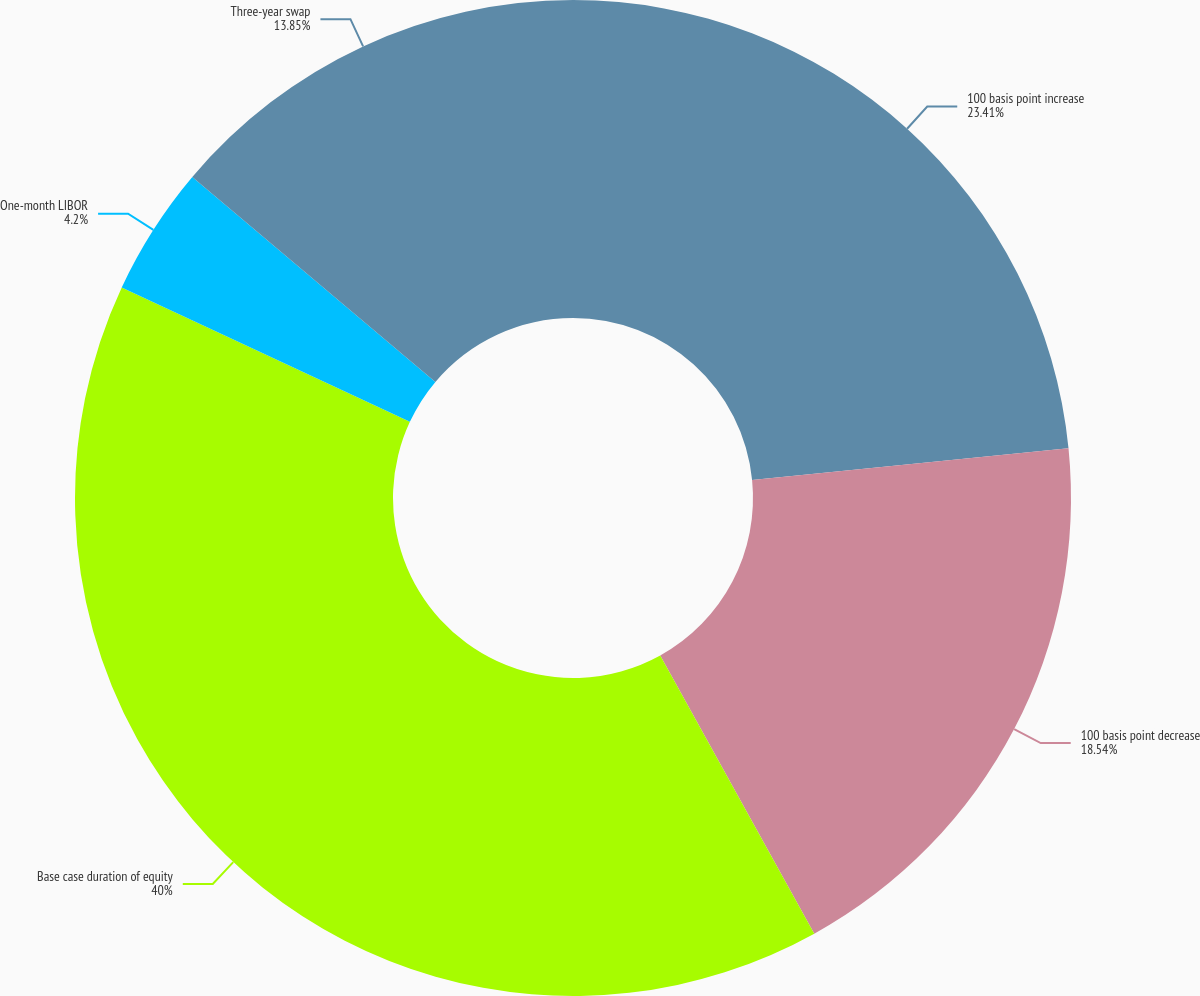Convert chart. <chart><loc_0><loc_0><loc_500><loc_500><pie_chart><fcel>100 basis point increase<fcel>100 basis point decrease<fcel>Base case duration of equity<fcel>One-month LIBOR<fcel>Three-year swap<nl><fcel>23.41%<fcel>18.54%<fcel>40.0%<fcel>4.2%<fcel>13.85%<nl></chart> 